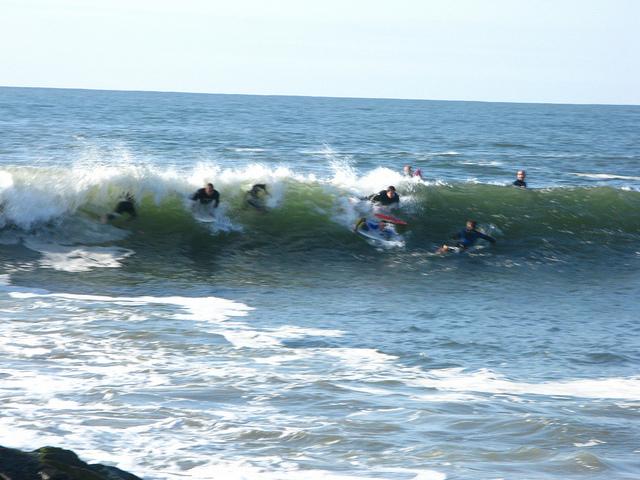Are the people swimming?
Keep it brief. No. Is the wave high?
Write a very short answer. Yes. How high are the waves?
Give a very brief answer. High. 